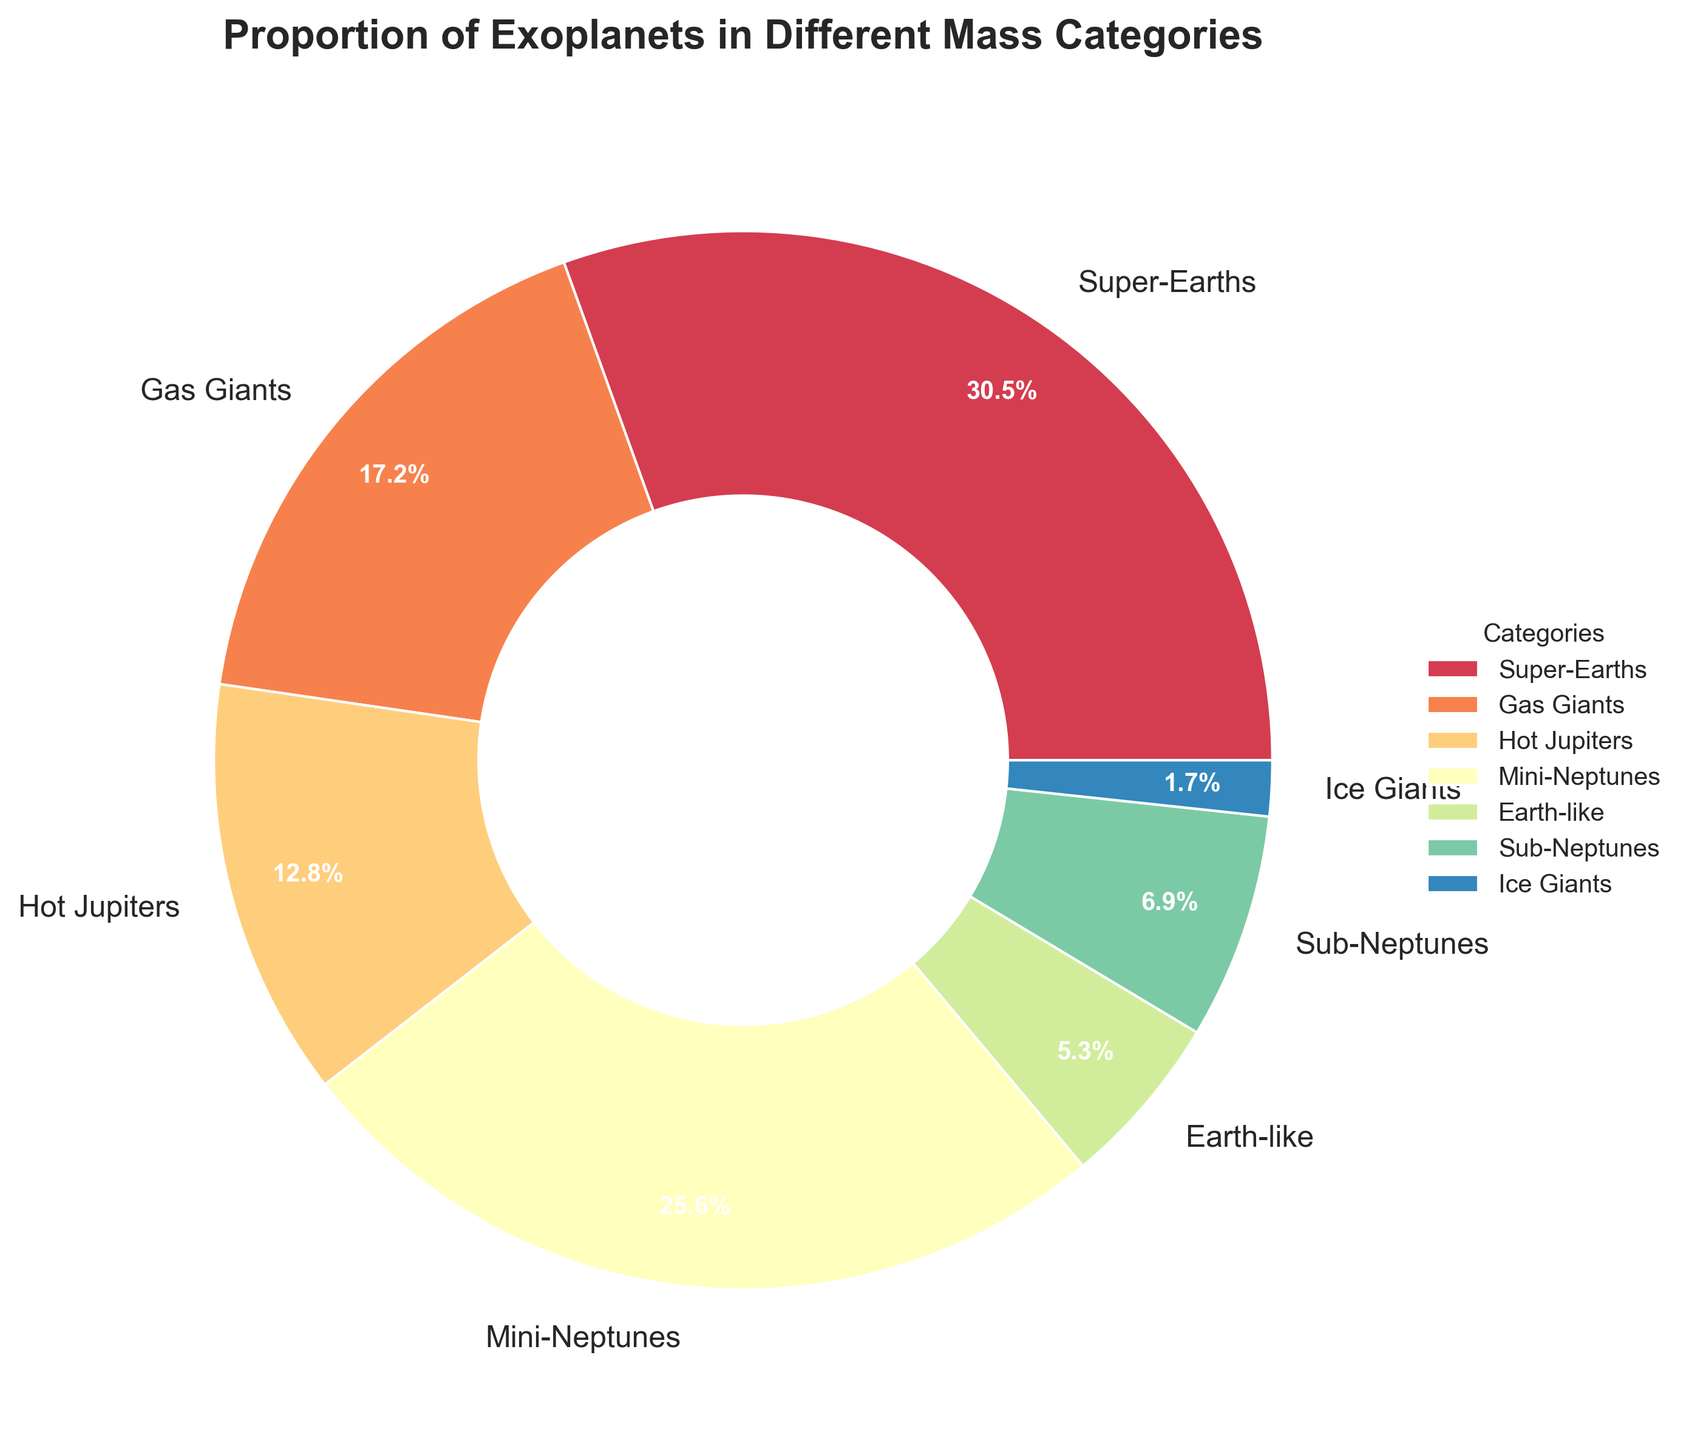What percentage of exoplanets are classified as Super-Earths? According to the pie chart, the segment labeled "Super-Earths" shows a percentage of 30.5%.
Answer: 30.5% Which two categories together make up the largest proportion of exoplanets? To find the largest combined proportion, add the percentages of various category pairs and compare. The combined percentages of Super-Earths (30.5%) and Mini-Neptunes (25.6%) yield 56.1%, which is the highest.
Answer: Super-Earths and Mini-Neptunes How much greater is the percentage of Super-Earths than Earth-like exoplanets? Subtract the percentage of Earth-like exoplanets (5.3%) from Super-Earths (30.5%). The calculation is 30.5% - 5.3% = 25.2%.
Answer: 25.2% Which category has the smallest proportion of exoplanets, and what is that proportion? The chart shows the smallest segment is labeled "Ice Giants," with a percentage of 1.7%.
Answer: Ice Giants, 1.7% What proportion of exoplanets are classified as either Sub-Neptunes or Ice Giants? Add the percentages of Sub-Neptunes (6.9%) and Ice Giants (1.7%). The calculation is 6.9% + 1.7% = 8.6%.
Answer: 8.6% Are there more Hot Jupiters or Gas Giants, and by how much? Compare the percentages for Hot Jupiters (12.8%) and Gas Giants (17.2%). Subtract the smaller from the larger: 17.2% - 12.8% = 4.4%.
Answer: Gas Giants, 4.4% What color represents Mini-Neptunes in the pie chart? The segment representing Mini-Neptunes is shaded using colors from a colormap. In this chart, Mini-Neptunes are colored in a distinct hue that can be visually identified from the other categories.
Answer: Answer depends on the visual observation from the chart What is the cumulative percentage of exoplanets classified as either Hot Jupiters, Sub-Neptunes, or Ice Giants? Sum the percentages for Hot Jupiters (12.8%), Sub-Neptunes (6.9%), and Ice Giants (1.7%). The calculation is 12.8% + 6.9% + 1.7% = 21.4%.
Answer: 21.4% Compare the combined proportion of Gas Giants and Super-Earths to that of Mini-Neptunes. The combined percentage for Gas Giants (17.2%) and Super-Earths (30.5%) is 47.7%. Compare this with Mini-Neptunes (25.6%) to find which is greater. The result shows that 47.7% > 25.6%.
Answer: Gas Giants and Super-Earths have a larger combined proportion What is the second most common category of exoplanets? By observing the pie chart, the second largest segment represents Mini-Neptunes with a percentage of 25.6%.
Answer: Mini-Neptunes 